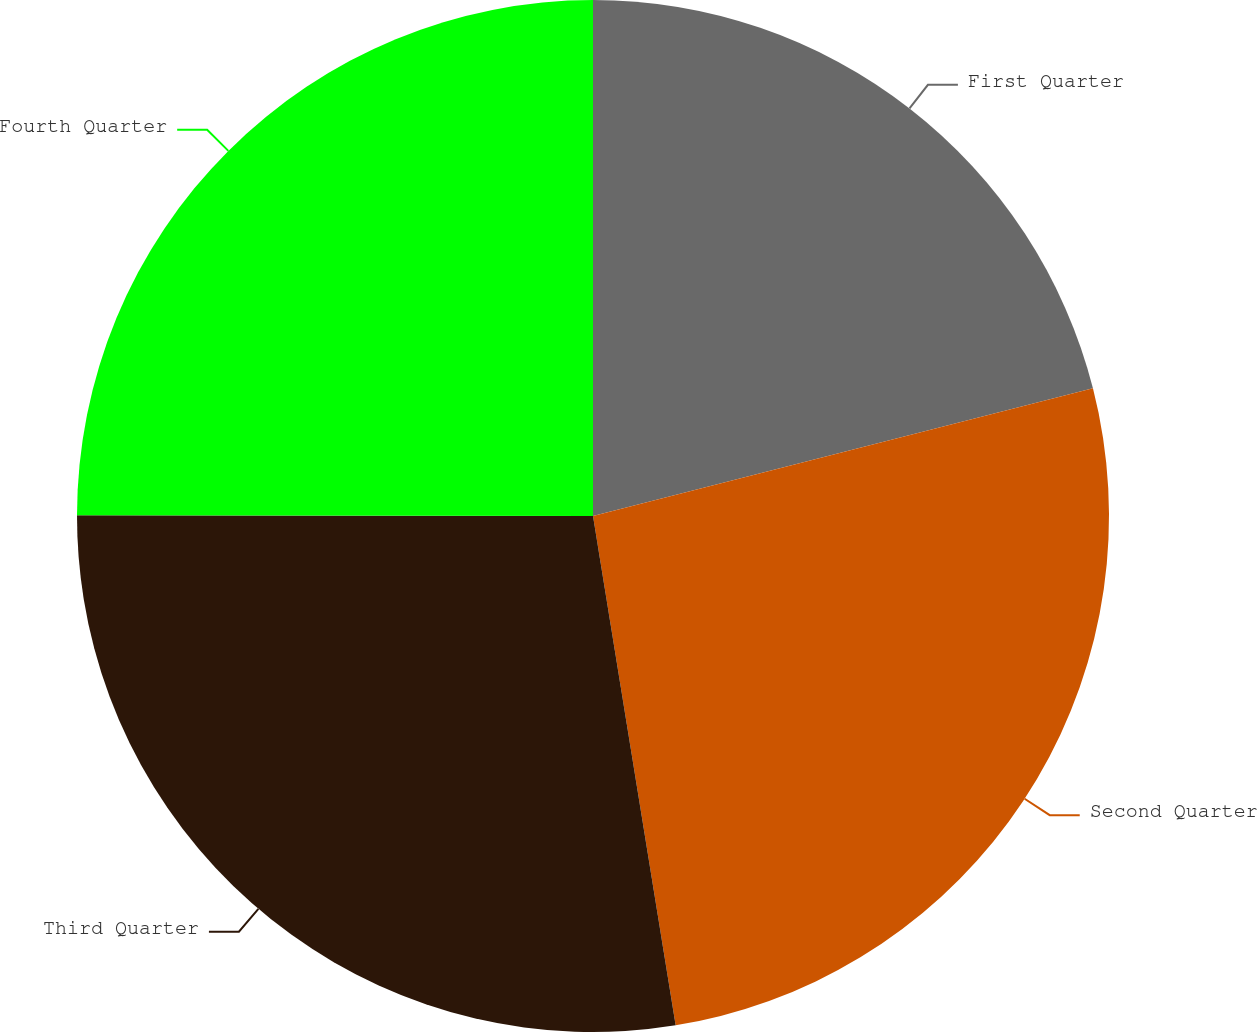Convert chart. <chart><loc_0><loc_0><loc_500><loc_500><pie_chart><fcel>First Quarter<fcel>Second Quarter<fcel>Third Quarter<fcel>Fourth Quarter<nl><fcel>21.02%<fcel>26.42%<fcel>27.58%<fcel>24.98%<nl></chart> 